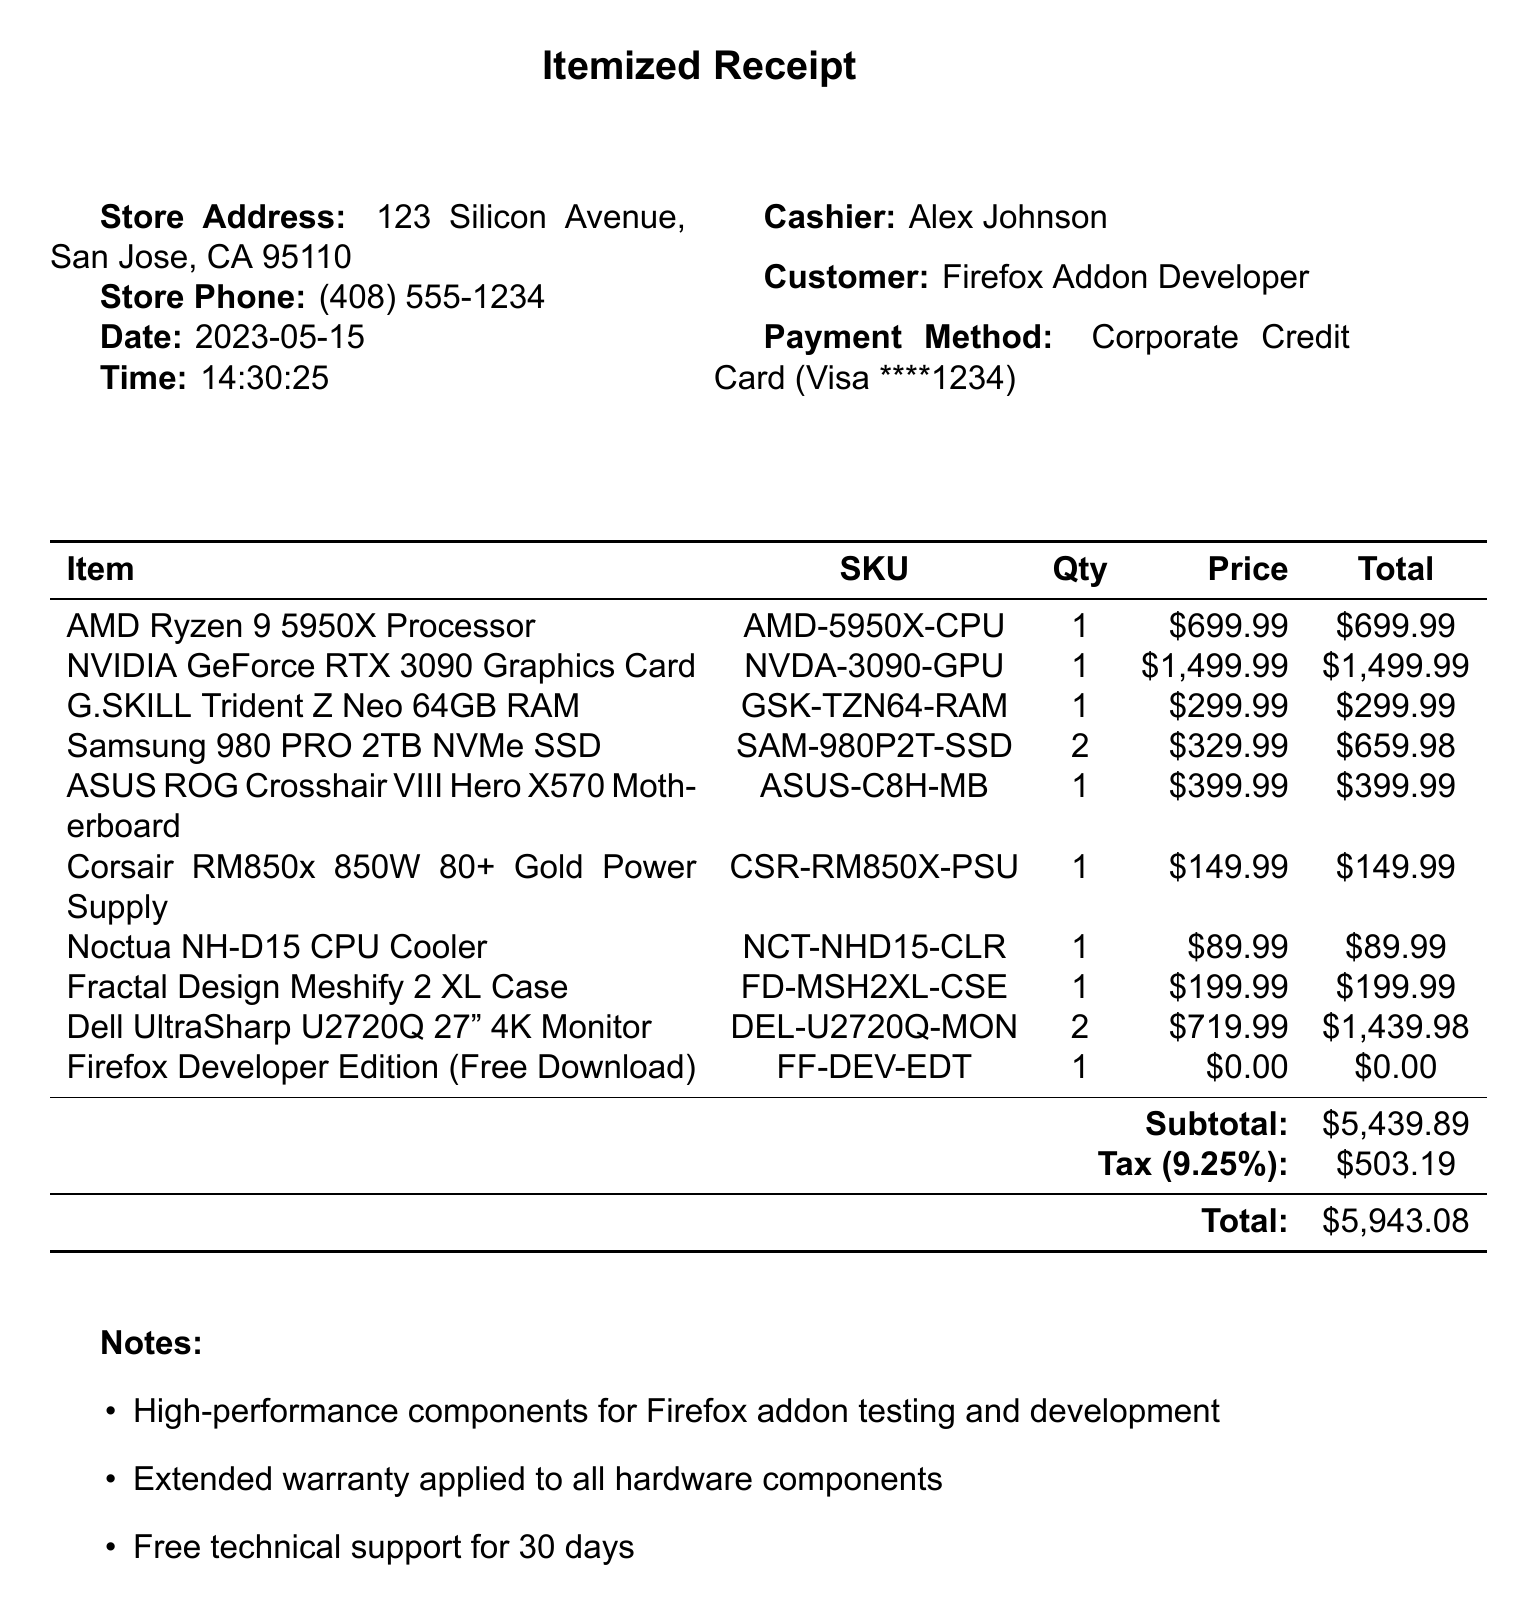What is the store name? The store name is located at the top of the document.
Answer: TechMaster Components What is the total amount? The total amount is a summary of the subtotal and tax at the bottom of the receipt.
Answer: 5943.08 What is the quantity of Samsung 980 PRO SSDs purchased? The quantity is specified next to the item in the table.
Answer: 2 Who was the cashier during the transaction? The cashier's name is listed in the document.
Answer: Alex Johnson What is the payment method used? The payment method is indicated below the customer information.
Answer: Corporate Credit Card What is the tax rate applied in this receipt? The tax rate is mentioned alongside the tax amount.
Answer: 0.0925 What type of warranty was applied to the hardware components? The notes section mentions this information directly.
Answer: Extended warranty What is the return policy duration for unopened items? The return policy is stated in the last section of the document.
Answer: 30-day return policy What is the SKU for the NVIDIA GeForce RTX 3090 Graphics Card? The SKU is listed in the itemized receipt next to the item name.
Answer: NVDA-3090-GPU How many Dell UltraSharp monitors were purchased? The quantity for the monitors is found in the itemized list.
Answer: 2 